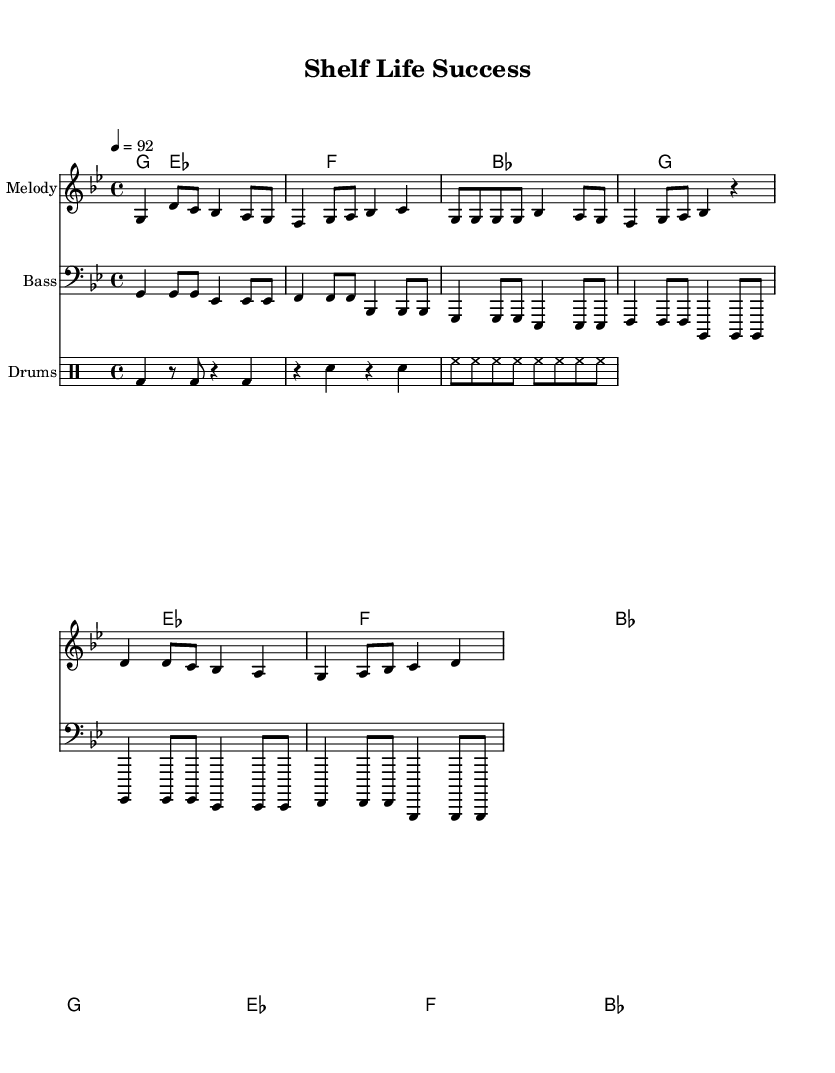what is the key signature of this music? The key signature is G minor, indicated by the presence of two flats in the key signature at the beginning of the sheet music.
Answer: G minor what is the time signature of this music? The time signature shown in the music sheet is 4/4, which is noted at the beginning and indicates there are four beats in each measure.
Answer: 4/4 what is the tempo marking for this piece? The tempo marking is quarter note equals 92, which indicates the speed of the piece and is found at the beginning of the score.
Answer: 92 how many measures are there in the chorus? The chorus section includes two measures, each featuring the lyrics and melody. By counting the notated measures with distinct lyrics, you can see there are two.
Answer: 2 what type of rhyme scheme is used in the verse lyrics? The verse employs an end-rhyme scheme where the last words of the phrases rhyme, which is typical in rap lyrics to create rhythm and flow. This can be verified by analyzing the end sounds of each line.
Answer: end-rhyme how many different instruments are indicated in the score? The score includes three distinct types of instrumental parts: melody, bass, and drums, which are labeled accordingly in the section for instrumental performance.
Answer: 3 what is the primary theme of the lyrics in this rap piece? The lyrics focus on product success and customer satisfaction, capturing the essence of successful merchandising and responsiveness to buyer feedback. This theme is evident in the verses and chorus.
Answer: success 